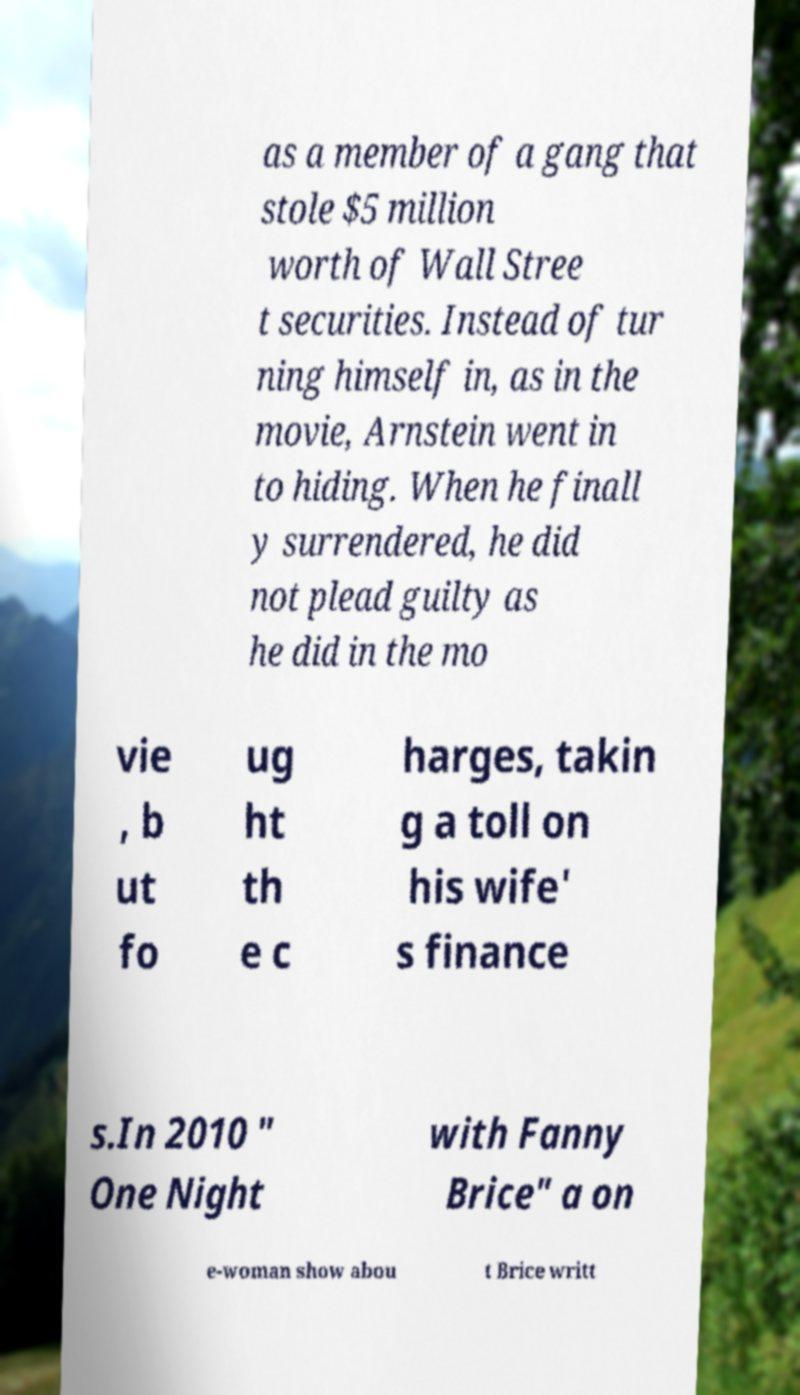There's text embedded in this image that I need extracted. Can you transcribe it verbatim? as a member of a gang that stole $5 million worth of Wall Stree t securities. Instead of tur ning himself in, as in the movie, Arnstein went in to hiding. When he finall y surrendered, he did not plead guilty as he did in the mo vie , b ut fo ug ht th e c harges, takin g a toll on his wife' s finance s.In 2010 " One Night with Fanny Brice" a on e-woman show abou t Brice writt 